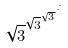<formula> <loc_0><loc_0><loc_500><loc_500>\sqrt { 3 } ^ { \sqrt { 3 } ^ { \sqrt { 3 } ^ { \cdot ^ { \cdot ^ { \cdot } } } } }</formula> 